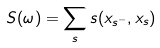<formula> <loc_0><loc_0><loc_500><loc_500>S ( \omega ) = \sum _ { s } s ( x _ { s ^ { - } } , x _ { s } )</formula> 